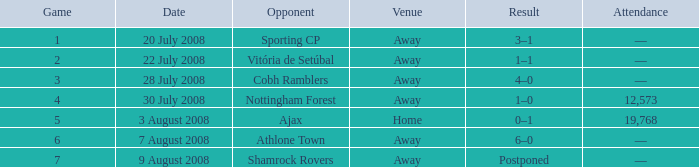What is the venue of game 3? Away. 